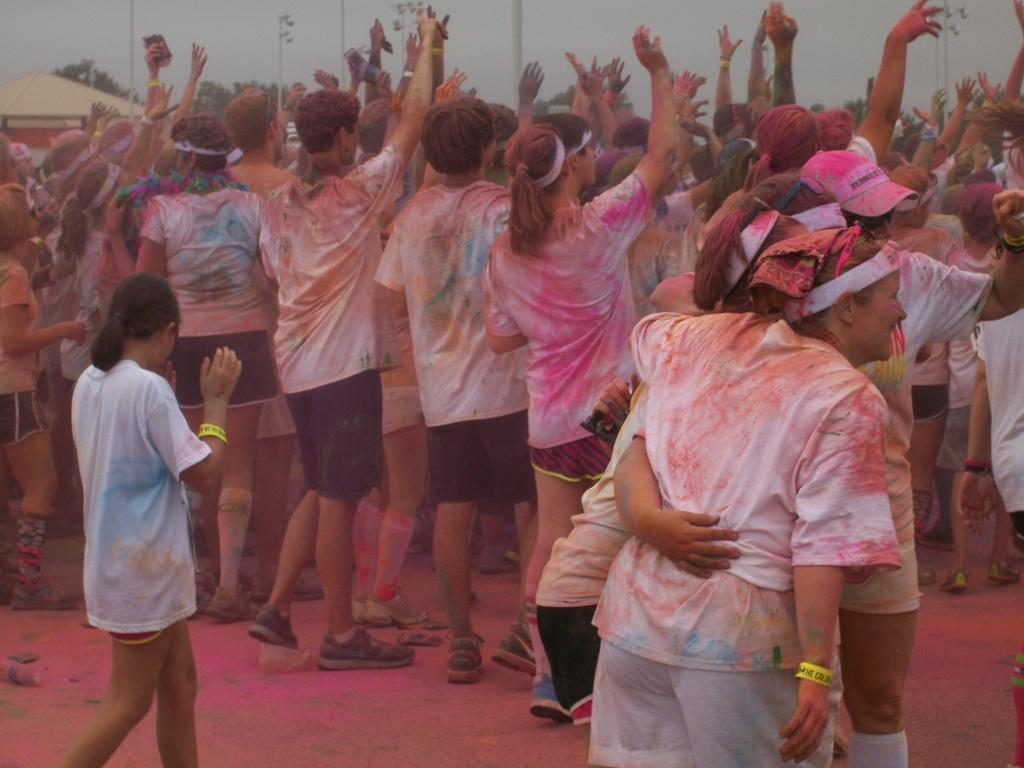What activity are the people in the image engaged in? People are playing Holi in the image. What can be seen in the background of the image? There are trees, poles, and sheds in the background of the image. What is visible at the bottom of the image? A: There is a road visible at the bottom of the image. Can you see a squirrel drinking soda in the image? There is no squirrel or soda present in the image. What type of crush is the person in the image experiencing? The image does not provide any information about the person's emotions or experiences, so it is impossible to determine if they are experiencing a crush. 